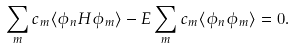<formula> <loc_0><loc_0><loc_500><loc_500>\sum _ { m } c _ { m } \langle \phi _ { n } H \phi _ { m } \rangle - E \sum _ { m } c _ { m } \langle \phi _ { n } \phi _ { m } \rangle = 0 .</formula> 